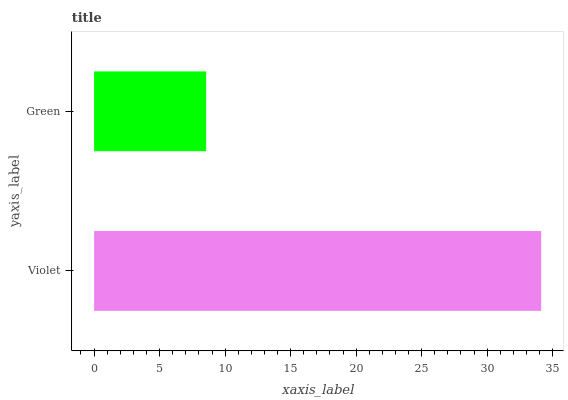Is Green the minimum?
Answer yes or no. Yes. Is Violet the maximum?
Answer yes or no. Yes. Is Green the maximum?
Answer yes or no. No. Is Violet greater than Green?
Answer yes or no. Yes. Is Green less than Violet?
Answer yes or no. Yes. Is Green greater than Violet?
Answer yes or no. No. Is Violet less than Green?
Answer yes or no. No. Is Violet the high median?
Answer yes or no. Yes. Is Green the low median?
Answer yes or no. Yes. Is Green the high median?
Answer yes or no. No. Is Violet the low median?
Answer yes or no. No. 